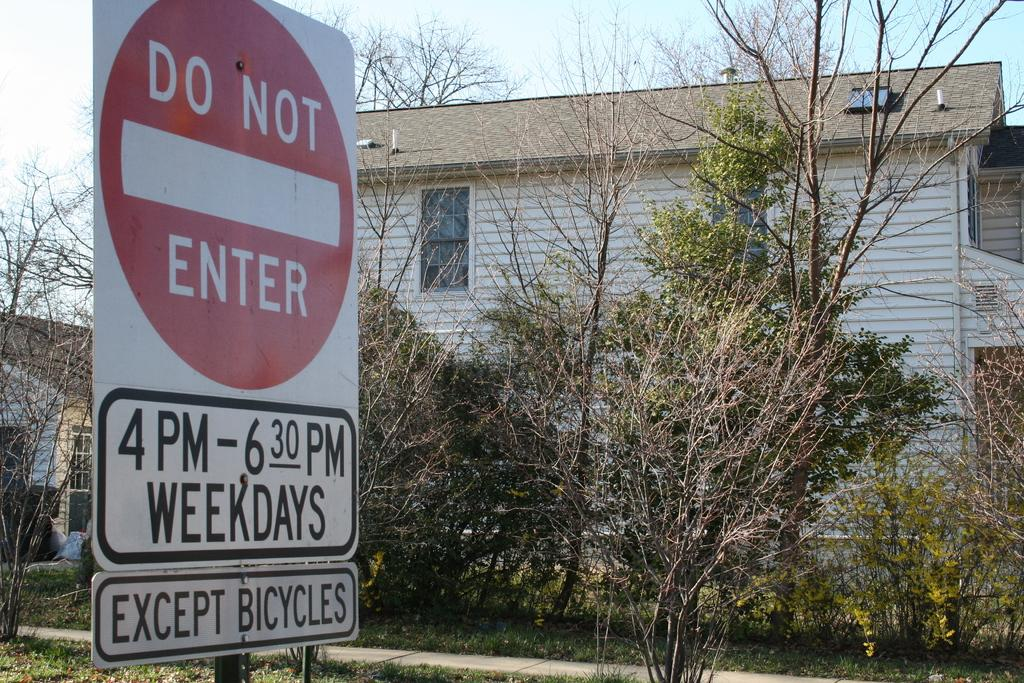What is present in the image that provides information or direction? There is a signboard in the image. What can be seen in the background of the image? There are trees and buildings in the background of the image. What type of oil can be seen dripping from the signboard in the image? There is no oil present in the image, nor is there any dripping from the signboard. What acoustics can be heard coming from the trees in the image? There is no sound or acoustics mentioned or visible in the image; it only shows a signboard and trees in the background. 